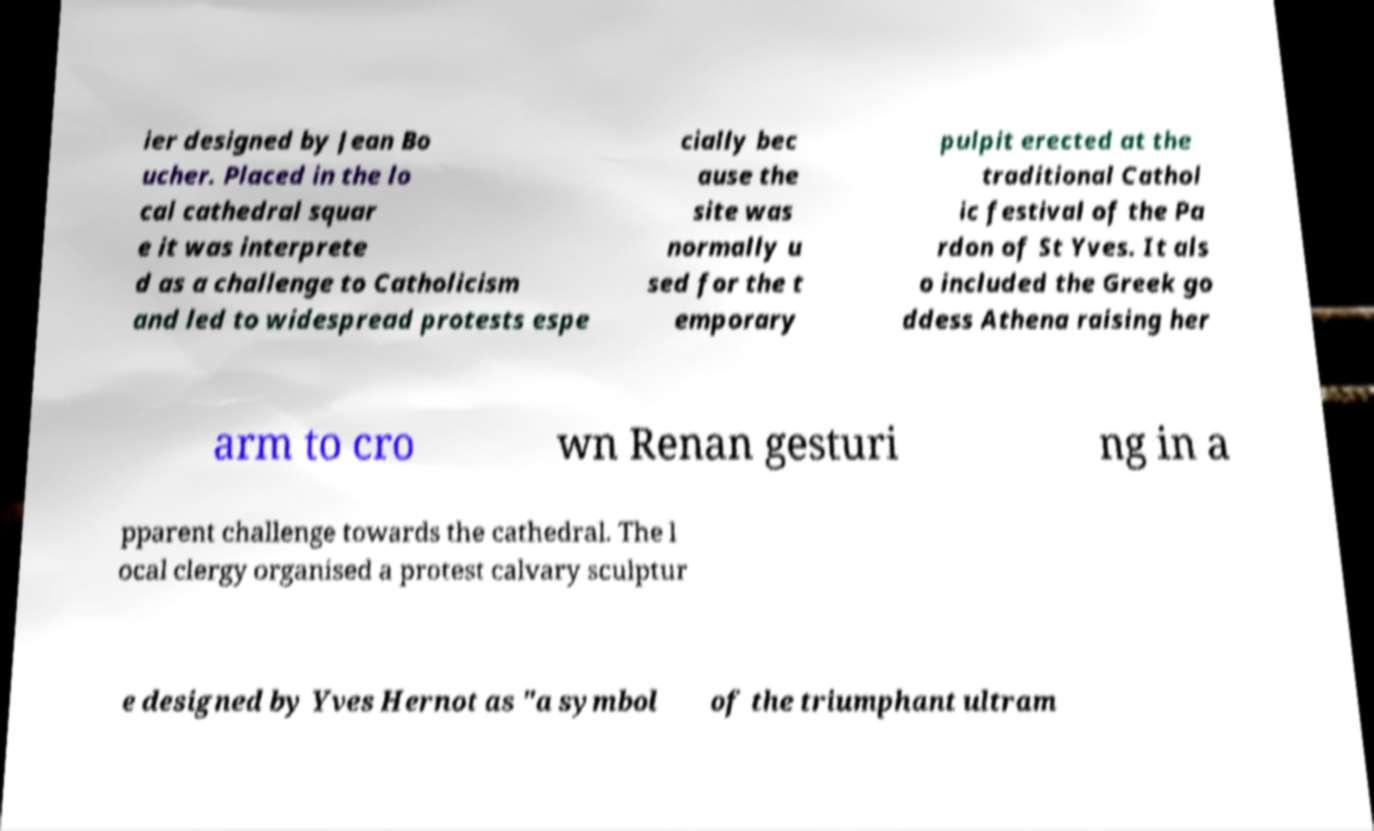Please identify and transcribe the text found in this image. ier designed by Jean Bo ucher. Placed in the lo cal cathedral squar e it was interprete d as a challenge to Catholicism and led to widespread protests espe cially bec ause the site was normally u sed for the t emporary pulpit erected at the traditional Cathol ic festival of the Pa rdon of St Yves. It als o included the Greek go ddess Athena raising her arm to cro wn Renan gesturi ng in a pparent challenge towards the cathedral. The l ocal clergy organised a protest calvary sculptur e designed by Yves Hernot as "a symbol of the triumphant ultram 